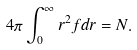Convert formula to latex. <formula><loc_0><loc_0><loc_500><loc_500>4 \pi \int _ { 0 } ^ { \infty } r ^ { 2 } f d r = N .</formula> 